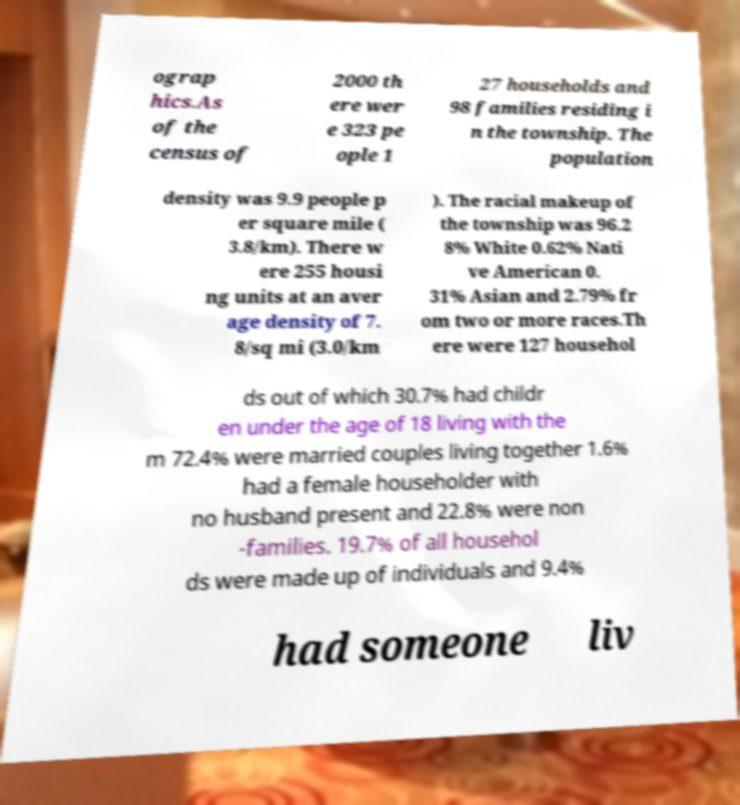Can you accurately transcribe the text from the provided image for me? ograp hics.As of the census of 2000 th ere wer e 323 pe ople 1 27 households and 98 families residing i n the township. The population density was 9.9 people p er square mile ( 3.8/km). There w ere 255 housi ng units at an aver age density of 7. 8/sq mi (3.0/km ). The racial makeup of the township was 96.2 8% White 0.62% Nati ve American 0. 31% Asian and 2.79% fr om two or more races.Th ere were 127 househol ds out of which 30.7% had childr en under the age of 18 living with the m 72.4% were married couples living together 1.6% had a female householder with no husband present and 22.8% were non -families. 19.7% of all househol ds were made up of individuals and 9.4% had someone liv 